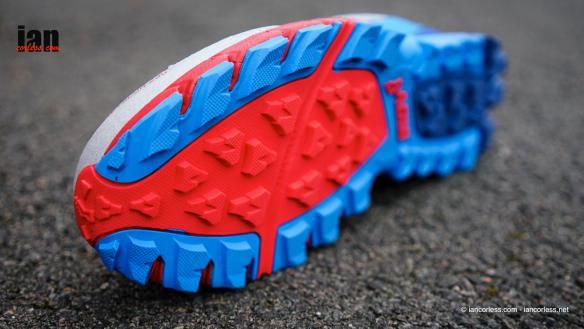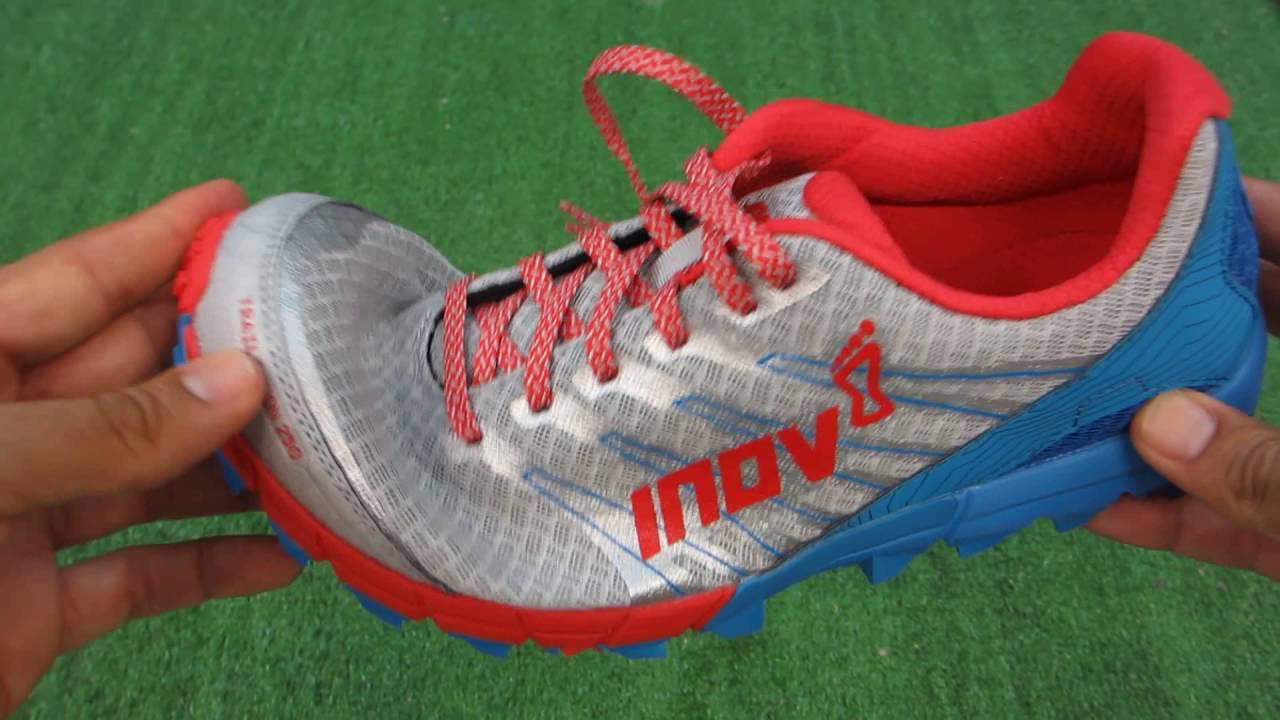The first image is the image on the left, the second image is the image on the right. Examine the images to the left and right. Is the description "An image shows the red and blue treaded sole of a sneaker." accurate? Answer yes or no. Yes. The first image is the image on the left, the second image is the image on the right. For the images displayed, is the sentence "One of the shoes in one of the images is turned on its side." factually correct? Answer yes or no. Yes. 